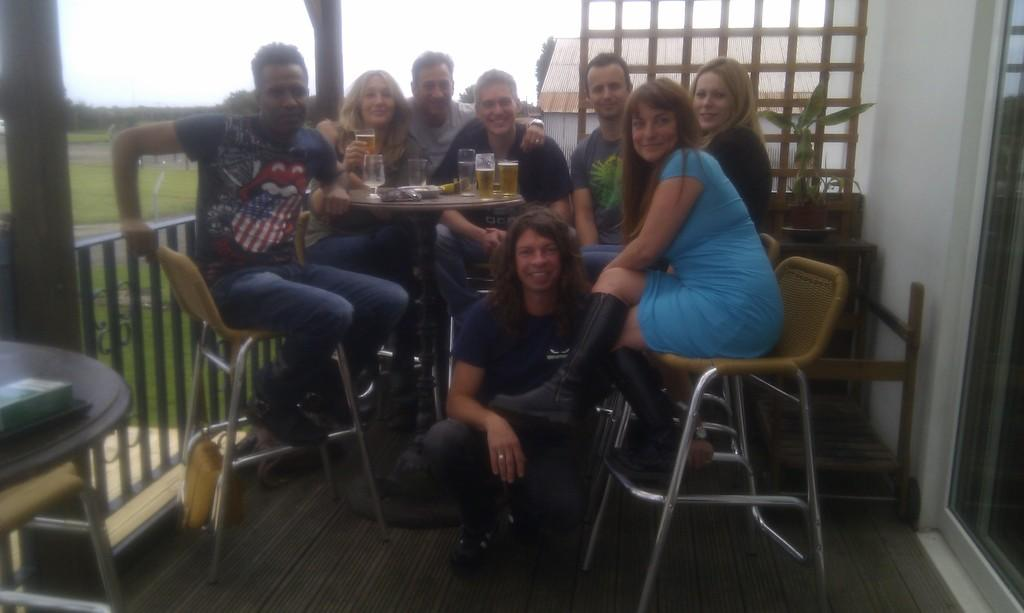How many people are in the group visible in the image? There is a group of people in the image, but the exact number cannot be determined from the provided facts. What is on the table in front of the group of people? There are wine glasses on a table in front of the group of people. What can be seen in the background of the image? Trees, the sky, and a house are visible in the background of the image. What type of insurance policy is being discussed by the group in the image? There is no indication in the image that the group is discussing any insurance policies. Can you see any ants crawling on the table in the image? There is no mention of ants in the provided facts, and therefore, we cannot determine if any are present in the image. 